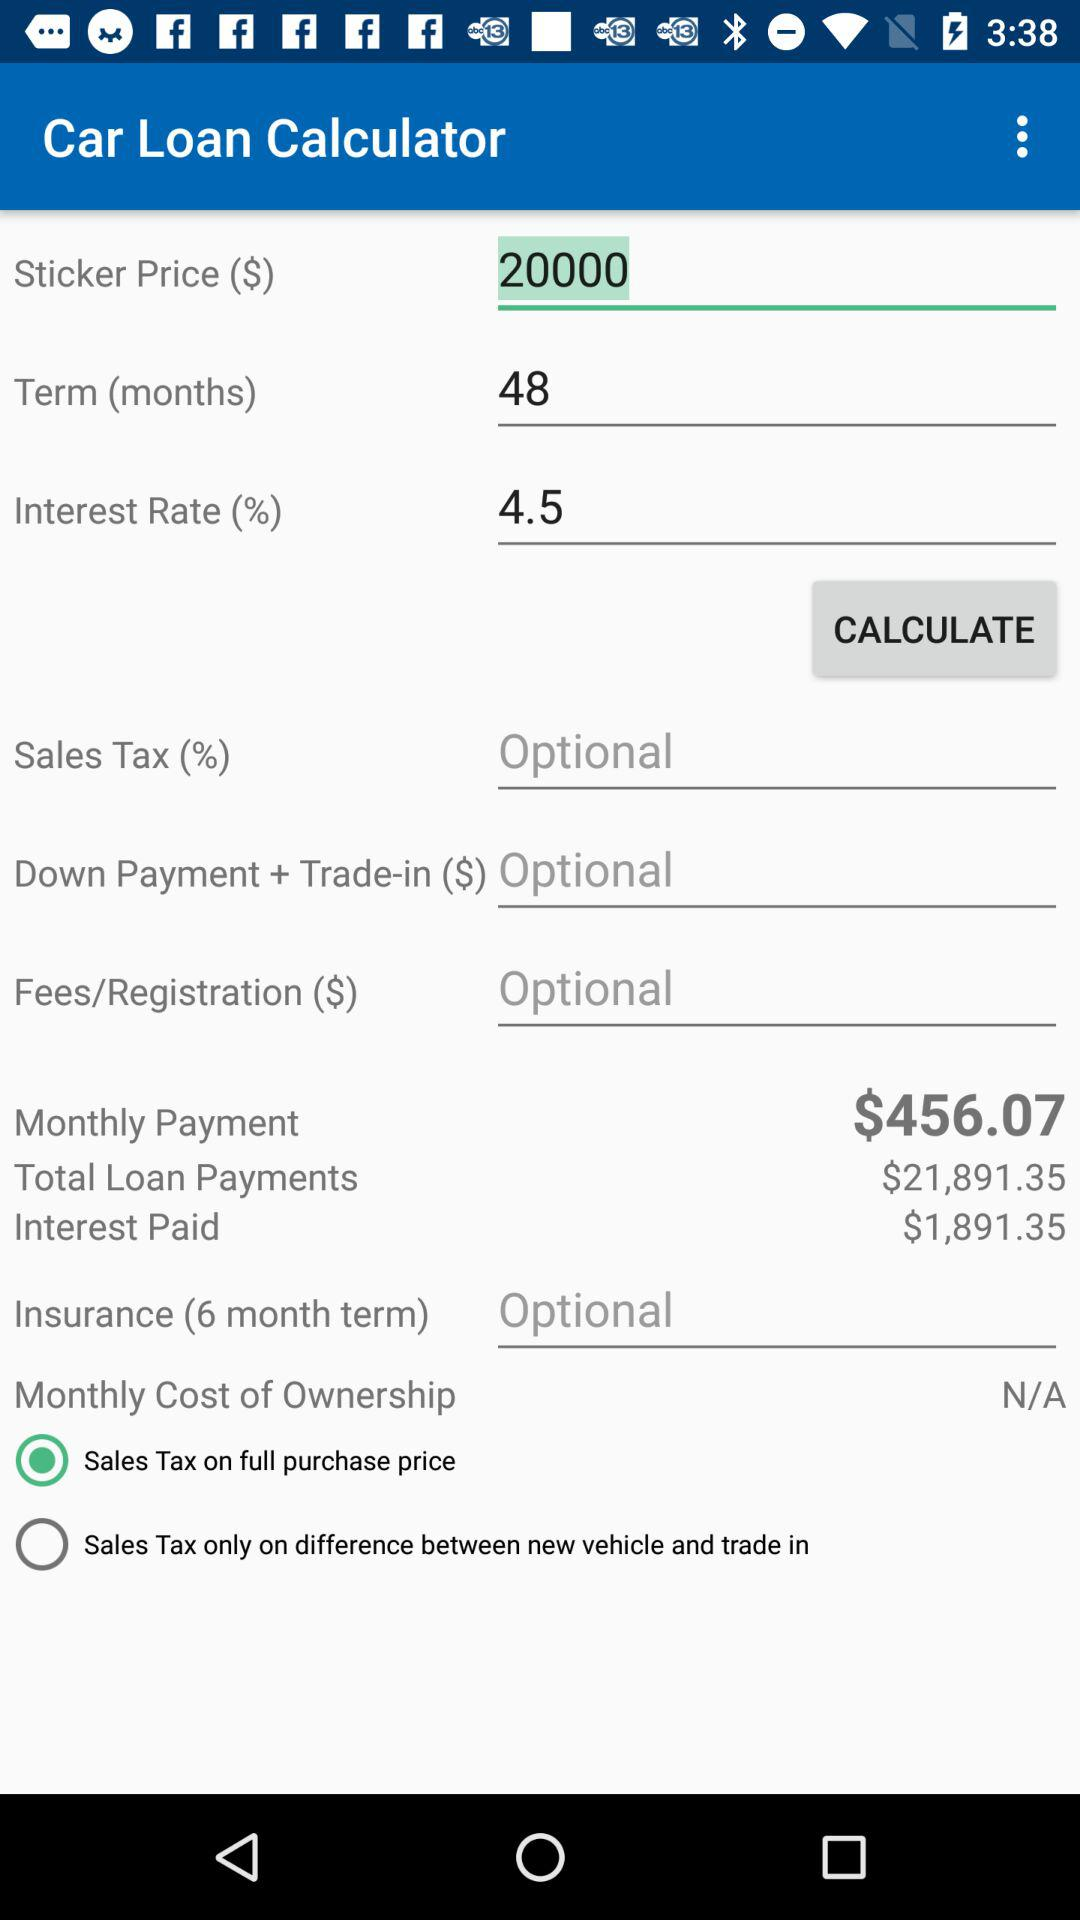What is the "Sticker Price"? The "Sticker Price" is 20000. 